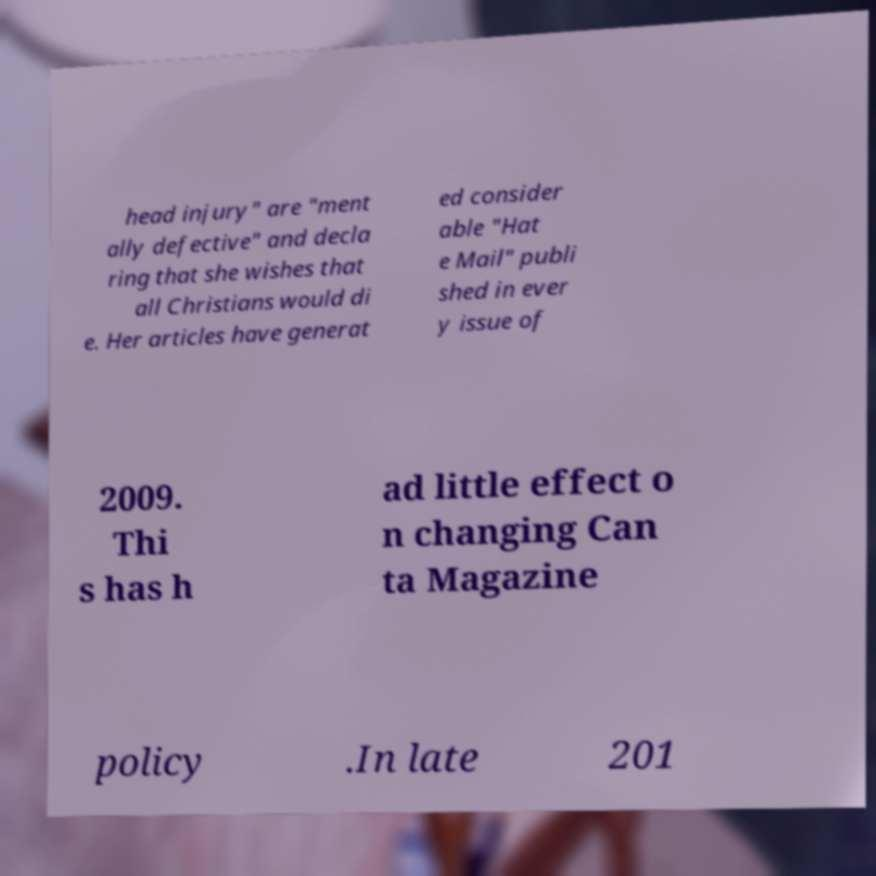What messages or text are displayed in this image? I need them in a readable, typed format. head injury" are "ment ally defective" and decla ring that she wishes that all Christians would di e. Her articles have generat ed consider able "Hat e Mail" publi shed in ever y issue of 2009. Thi s has h ad little effect o n changing Can ta Magazine policy .In late 201 